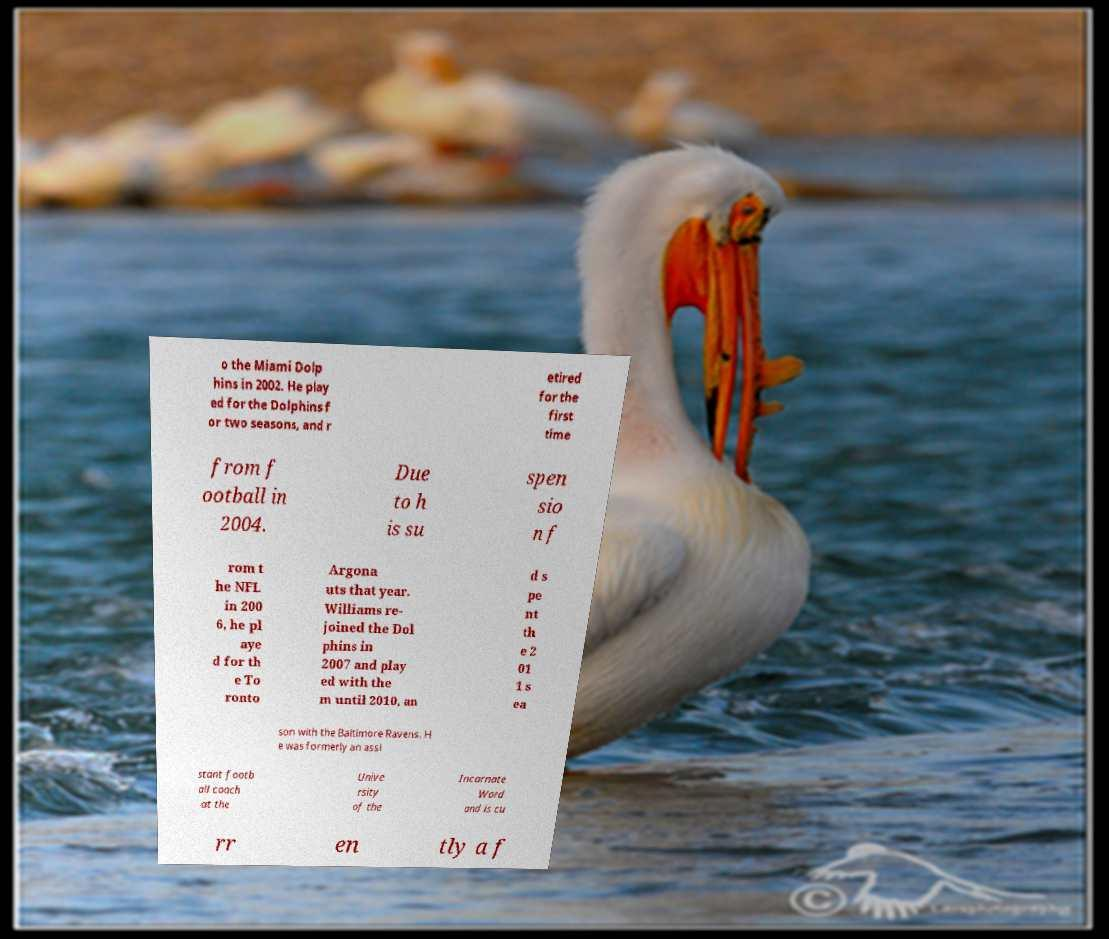Please identify and transcribe the text found in this image. o the Miami Dolp hins in 2002. He play ed for the Dolphins f or two seasons, and r etired for the first time from f ootball in 2004. Due to h is su spen sio n f rom t he NFL in 200 6, he pl aye d for th e To ronto Argona uts that year. Williams re- joined the Dol phins in 2007 and play ed with the m until 2010, an d s pe nt th e 2 01 1 s ea son with the Baltimore Ravens. H e was formerly an assi stant footb all coach at the Unive rsity of the Incarnate Word and is cu rr en tly a f 